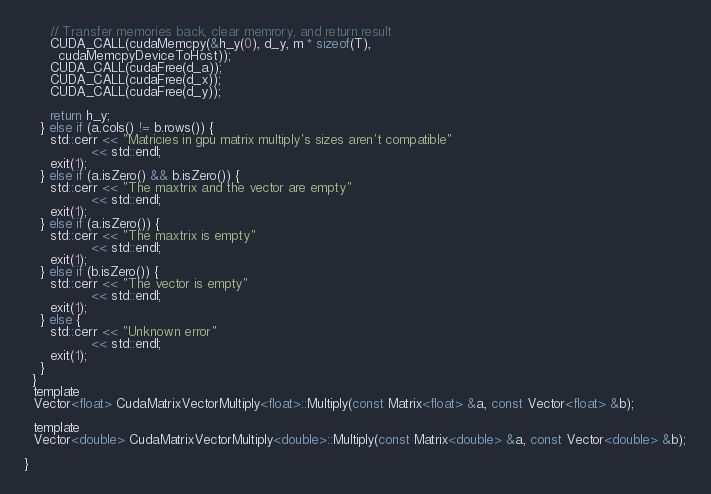Convert code to text. <code><loc_0><loc_0><loc_500><loc_500><_Cuda_>      // Transfer memories back, clear memrory, and return result
      CUDA_CALL(cudaMemcpy(&h_y(0), d_y, m * sizeof(T),
        cudaMemcpyDeviceToHost));
      CUDA_CALL(cudaFree(d_a));
      CUDA_CALL(cudaFree(d_x));
      CUDA_CALL(cudaFree(d_y));

      return h_y;
    } else if (a.cols() != b.rows()) {
      std::cerr << "Matricies in gpu matrix multiply's sizes aren't compatible"
                << std::endl;
      exit(1);
    } else if (a.isZero() && b.isZero()) {
      std::cerr << "The maxtrix and the vector are empty"
                << std::endl;
      exit(1);
    } else if (a.isZero()) {
      std::cerr << "The maxtrix is empty"
                << std::endl;
      exit(1);
    } else if (b.isZero()) {
      std::cerr << "The vector is empty"
                << std::endl;
      exit(1);
    } else {
      std::cerr << "Unknown error"
                << std::endl;
      exit(1);
    }
  }
  template
  Vector<float> CudaMatrixVectorMultiply<float>::Multiply(const Matrix<float> &a, const Vector<float> &b);

  template
  Vector<double> CudaMatrixVectorMultiply<double>::Multiply(const Matrix<double> &a, const Vector<double> &b);

}
</code> 